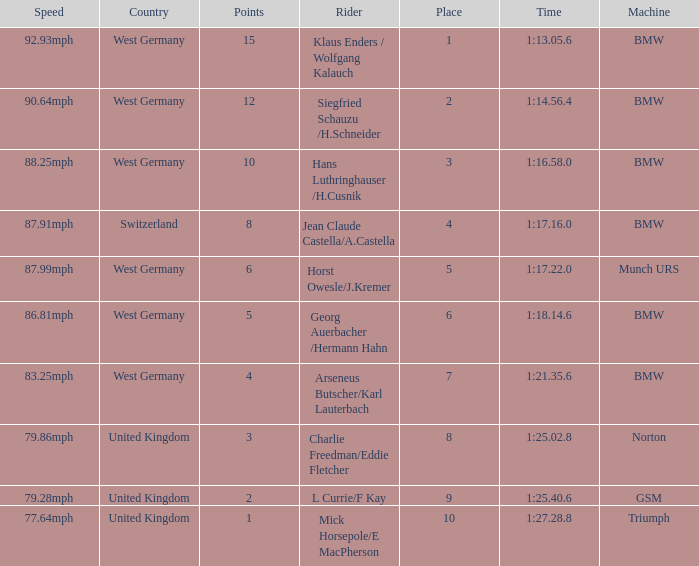Which places have points larger than 10? None. 